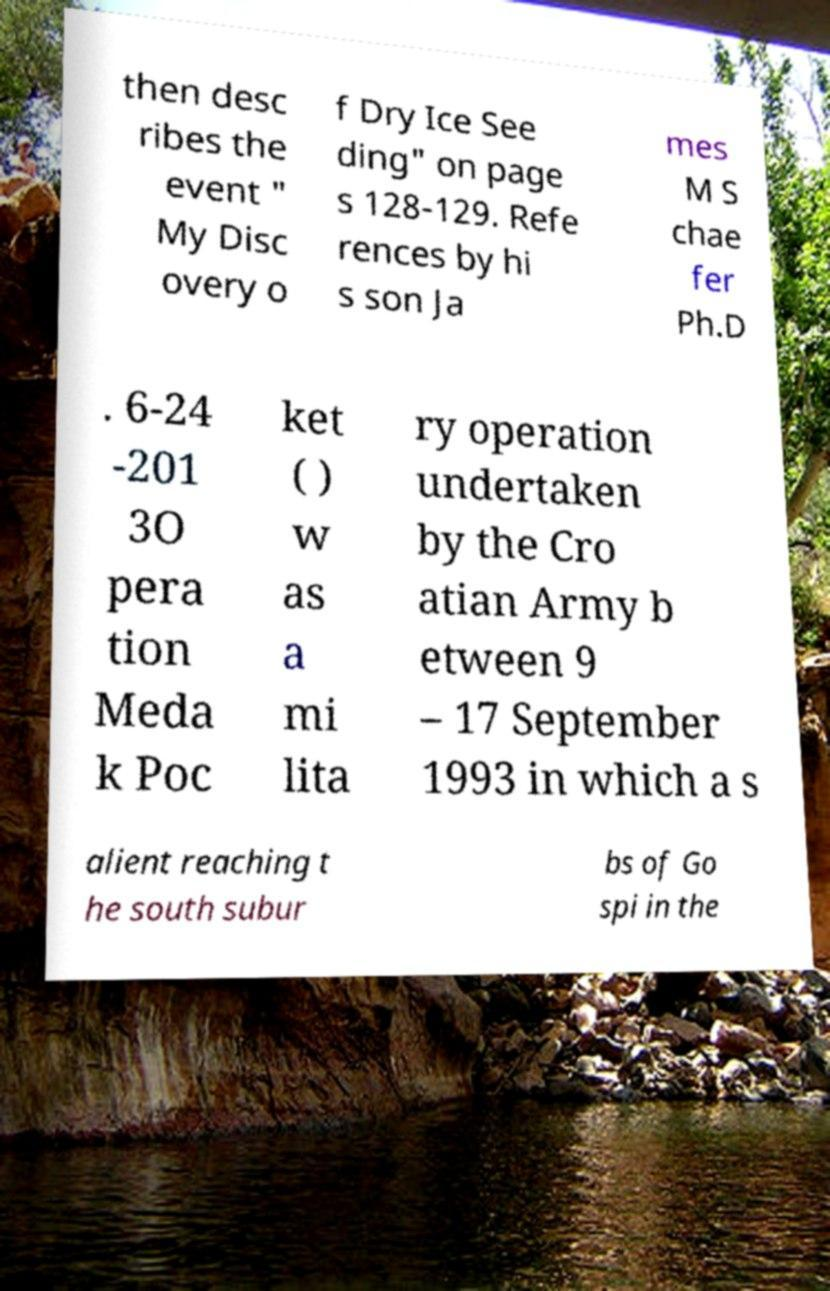Could you extract and type out the text from this image? then desc ribes the event " My Disc overy o f Dry Ice See ding" on page s 128-129. Refe rences by hi s son Ja mes M S chae fer Ph.D . 6-24 -201 3O pera tion Meda k Poc ket ( ) w as a mi lita ry operation undertaken by the Cro atian Army b etween 9 – 17 September 1993 in which a s alient reaching t he south subur bs of Go spi in the 